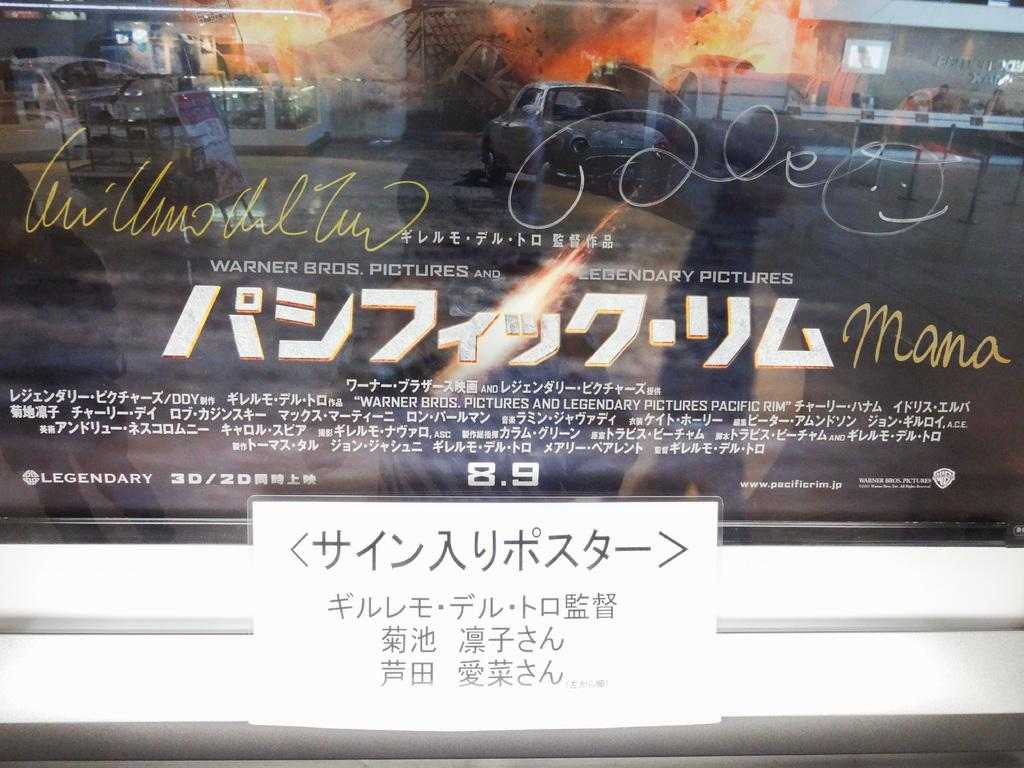<image>
Describe the image concisely. Poster that says "Warner Bros. Pictures" behind a small white piece of paper. 